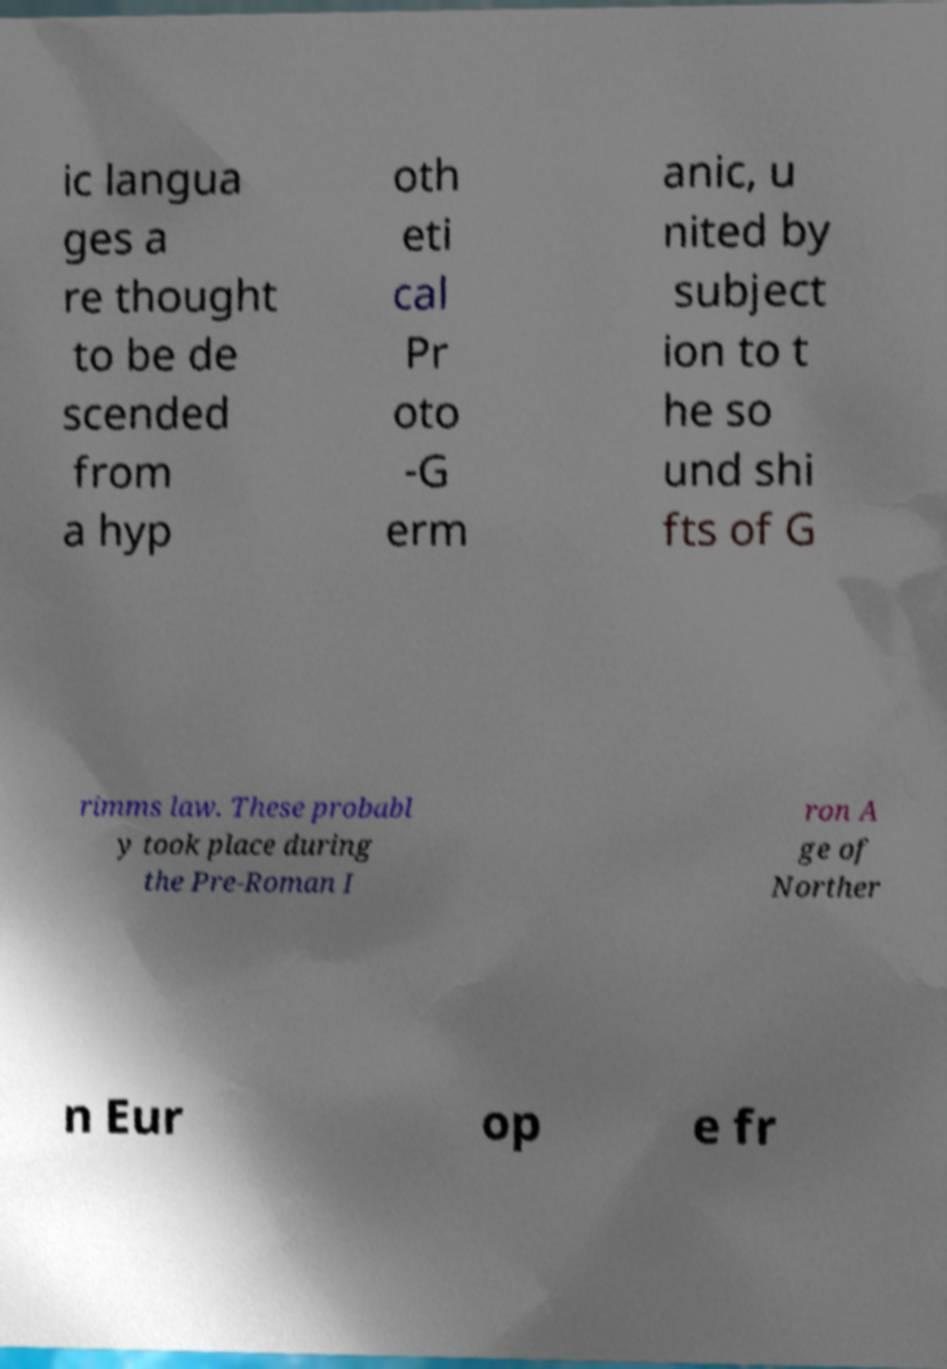For documentation purposes, I need the text within this image transcribed. Could you provide that? ic langua ges a re thought to be de scended from a hyp oth eti cal Pr oto -G erm anic, u nited by subject ion to t he so und shi fts of G rimms law. These probabl y took place during the Pre-Roman I ron A ge of Norther n Eur op e fr 